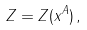Convert formula to latex. <formula><loc_0><loc_0><loc_500><loc_500>Z = Z ( x ^ { A } ) \, ,</formula> 